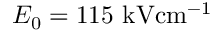<formula> <loc_0><loc_0><loc_500><loc_500>E _ { 0 } = 1 1 5 { k V c m ^ { - 1 } }</formula> 